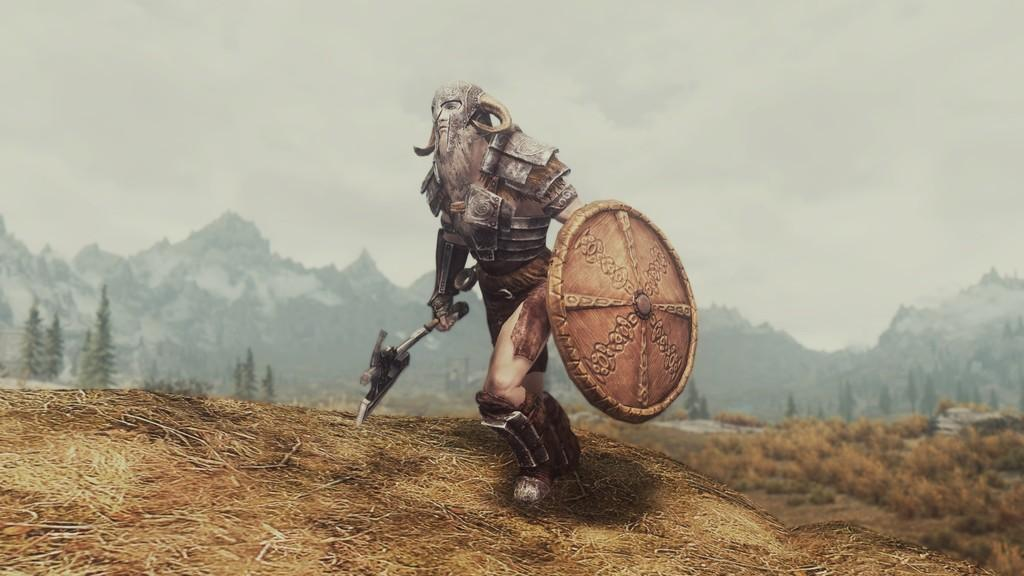What is the main subject of the image? There is a depiction of a warrior in the image. What type of natural environment is shown in the image? There are trees and mountains in the image. What is visible in the background of the image? The sky is visible in the image. Can you see any deer in the image? There are no deer present in the image. What type of beam is holding up the warrior in the image? The warrior is a depiction and not a physical object, so there is no beam holding it up. 